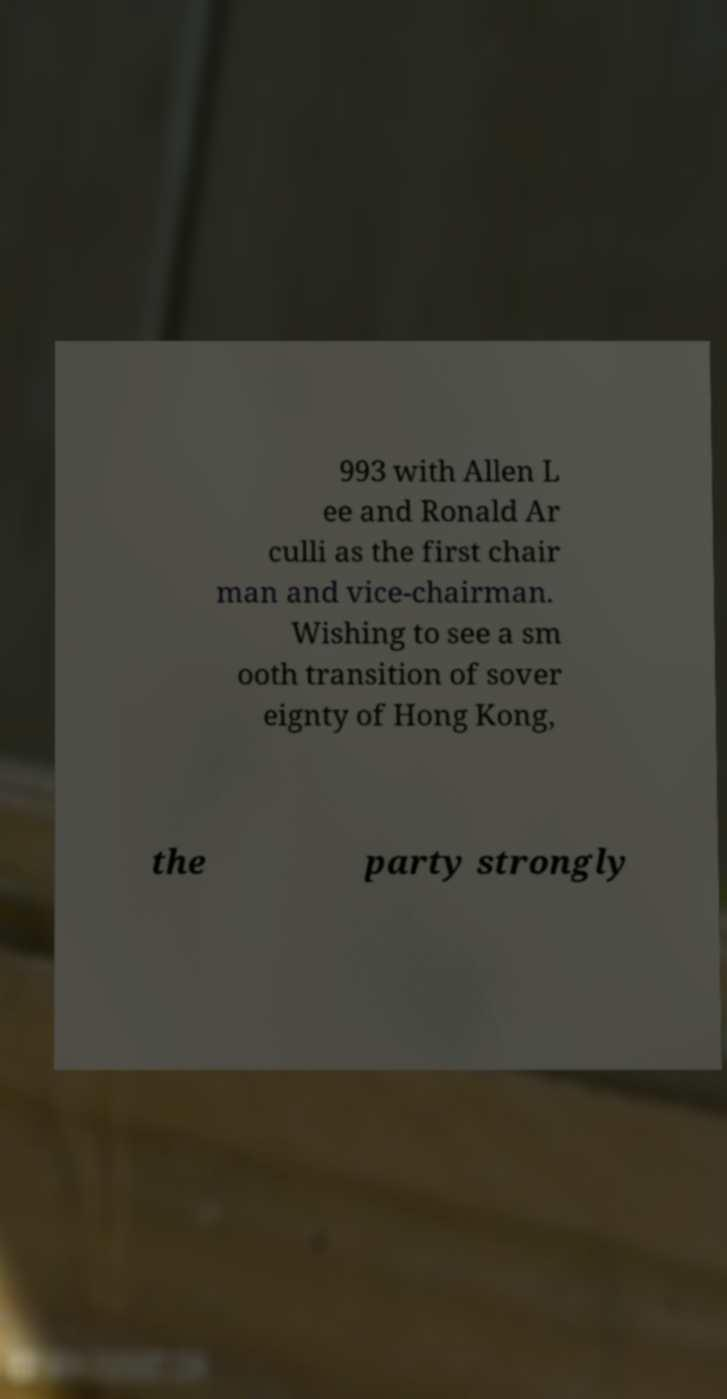Can you accurately transcribe the text from the provided image for me? 993 with Allen L ee and Ronald Ar culli as the first chair man and vice-chairman. Wishing to see a sm ooth transition of sover eignty of Hong Kong, the party strongly 